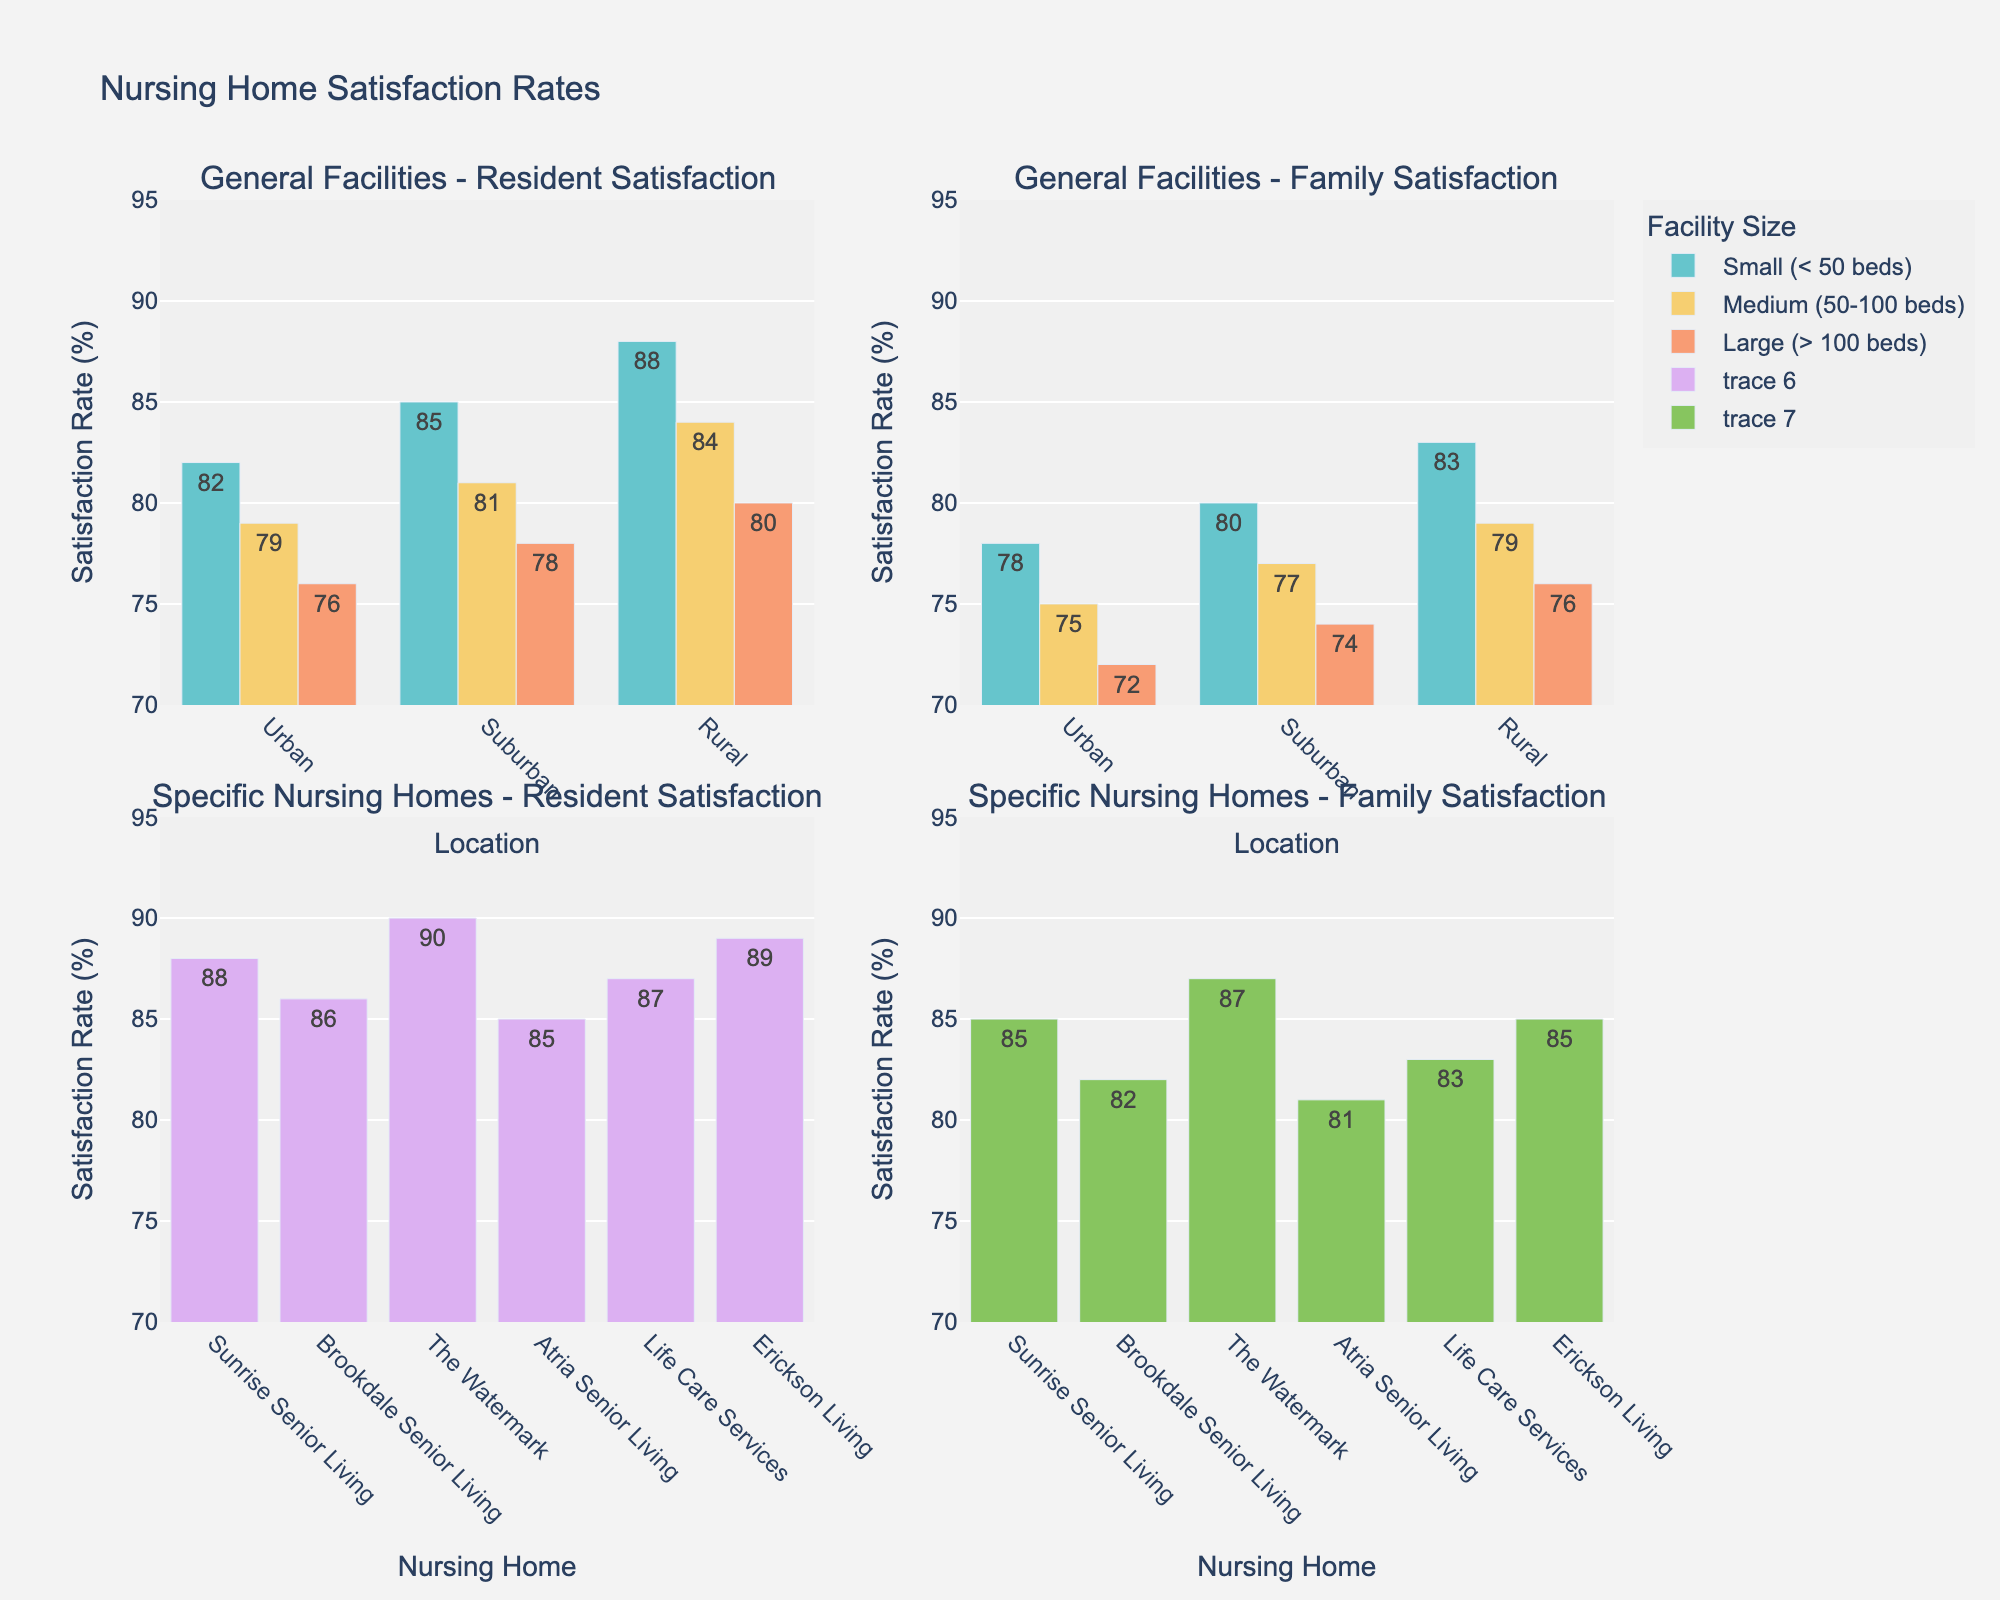What is the title of the figure? The title of the figure is located at the top and it summarizes the overall content of the plots. It reads "Nursing Home Satisfaction Rates".
Answer: Nursing Home Satisfaction Rates What axis labels are used in the first subplot (top-left)? In the top-left subplot, the x-axis is labeled as "Location" and the y-axis is labeled as "Satisfaction Rate (%)".
Answer: Location (x-axis) and Satisfaction Rate (%) (y-axis) Which facility size in urban locations has the highest resident satisfaction rate according to the figure? In the top-left subplot, look at the bars corresponding to urban locations for different facility sizes. The highest resident satisfaction rate for Urban locations is in Small (< 50 beds) with a value of 82%.
Answer: Small (< 50 beds) How many specific nursing homes are included in the figure? In the bottom-left subplot, count the distinct nursing home names on the x-axis. There are six specific nursing homes listed.
Answer: Six What is the difference in family satisfaction between Small and Large facilities in rural locations? In the top-right subplot, compare the family satisfaction rates for Small and Large facilities in rural locations. Small facilities have 83% and Large facilities have 76%, the difference is 83 - 76 = 7%.
Answer: 7% How does family satisfaction in suburban locations compare across different facility sizes? In the top-right subplot, compare the heights of the bars for suburban locations across Small, Medium, and Large facilities. Small facilities have 80%, Medium facilities have 77%, and Large facilities have 74%.
Answer: Small > Medium > Large Which specific nursing home shows the highest resident satisfaction rate? In the bottom-left subplot, compare the heights of the bars representing each specific nursing home. The nursing home with the highest bar is The Watermark with a resident satisfaction rate of 90%.
Answer: The Watermark In urban locations, what is the difference in resident satisfaction between Atria Senior Living and Medium-sized (50-100 beds) facilities? In the top-left subplot, compare the bar heights for Atria Senior Living and Medium-sized (50-100 beds) facilities in urban locations. Atria Senior Living has 85% and Medium facilities have 79%, the difference is 85 - 79 = 6%.
Answer: 6% Which facility type has the lowest family satisfaction rate overall? Examine the bottom-right subplot where family satisfaction of specific nursing homes and the top-right subplot where general facilities are represented. The lowest family satisfaction rate overall is for the Large (> 100 beds) facilities in Urban locations with 72%.
Answer: Large (> 100 beds) Urban Is the average resident satisfaction higher in specific nursing homes or general rural facilities? Calculate the average resident satisfaction rate for specific nursing homes and general rural facilities. For specific nursing homes: (88 + 86 + 90 + 85 + 87 + 89)/6 = 87.5%. For general rural facilities: (88 + 84 + 80)/3 = 84%.
Answer: Specific nursing homes 